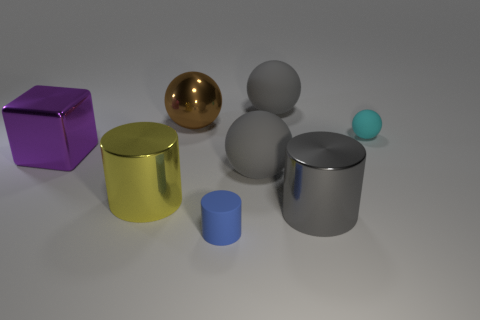What material is the big cylinder right of the rubber thing in front of the big yellow metallic cylinder made of?
Offer a very short reply. Metal. The brown metallic object has what shape?
Your answer should be compact. Sphere. Is the number of metal objects left of the big gray metal thing the same as the number of big gray things that are in front of the purple thing?
Keep it short and to the point. No. There is a big object that is in front of the yellow metal object; does it have the same color as the large rubber thing that is behind the big block?
Keep it short and to the point. Yes. Are there more big yellow things that are on the left side of the big purple thing than cylinders?
Ensure brevity in your answer.  No. There is a yellow object that is the same material as the cube; what is its shape?
Your answer should be compact. Cylinder. Does the gray ball that is behind the cyan sphere have the same size as the purple thing?
Keep it short and to the point. Yes. There is a shiny thing right of the small thing on the left side of the gray cylinder; what is its shape?
Provide a succinct answer. Cylinder. What is the size of the rubber object that is to the right of the matte object that is behind the cyan matte object?
Give a very brief answer. Small. What color is the metallic thing to the left of the big yellow object?
Provide a succinct answer. Purple. 